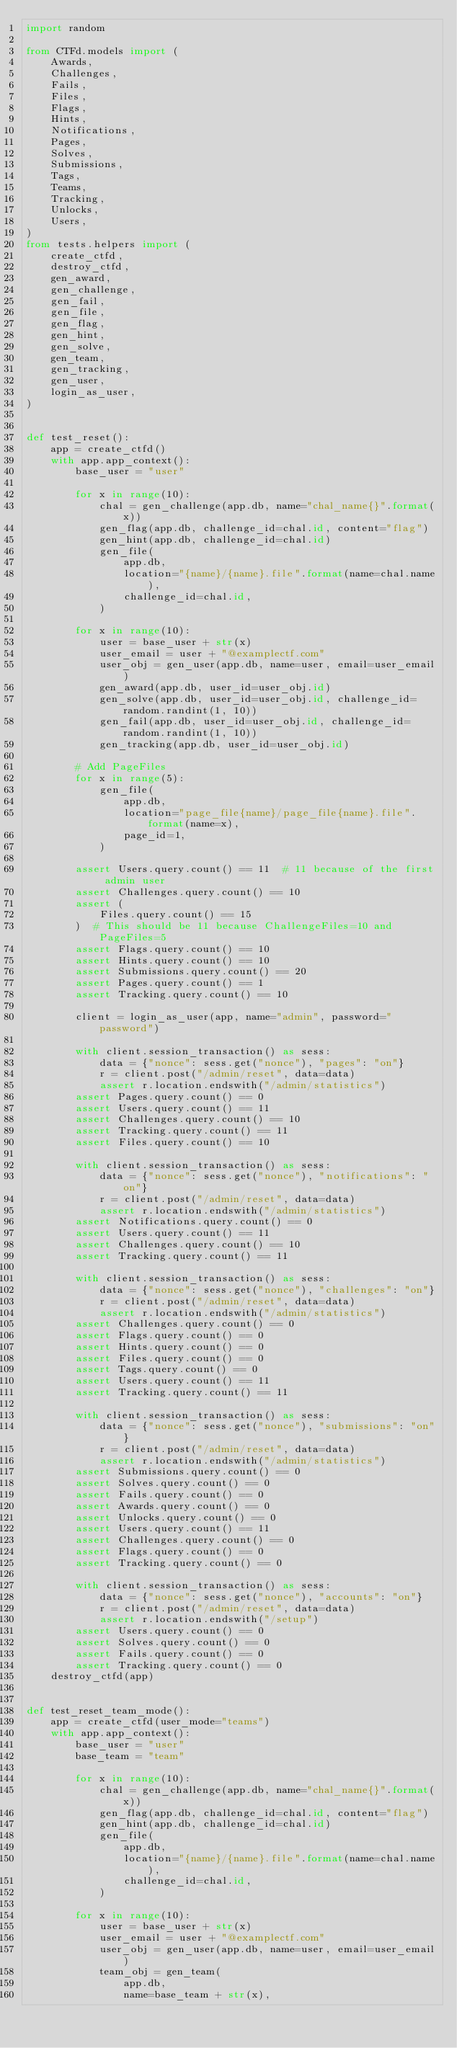<code> <loc_0><loc_0><loc_500><loc_500><_Python_>import random

from CTFd.models import (
    Awards,
    Challenges,
    Fails,
    Files,
    Flags,
    Hints,
    Notifications,
    Pages,
    Solves,
    Submissions,
    Tags,
    Teams,
    Tracking,
    Unlocks,
    Users,
)
from tests.helpers import (
    create_ctfd,
    destroy_ctfd,
    gen_award,
    gen_challenge,
    gen_fail,
    gen_file,
    gen_flag,
    gen_hint,
    gen_solve,
    gen_team,
    gen_tracking,
    gen_user,
    login_as_user,
)


def test_reset():
    app = create_ctfd()
    with app.app_context():
        base_user = "user"

        for x in range(10):
            chal = gen_challenge(app.db, name="chal_name{}".format(x))
            gen_flag(app.db, challenge_id=chal.id, content="flag")
            gen_hint(app.db, challenge_id=chal.id)
            gen_file(
                app.db,
                location="{name}/{name}.file".format(name=chal.name),
                challenge_id=chal.id,
            )

        for x in range(10):
            user = base_user + str(x)
            user_email = user + "@examplectf.com"
            user_obj = gen_user(app.db, name=user, email=user_email)
            gen_award(app.db, user_id=user_obj.id)
            gen_solve(app.db, user_id=user_obj.id, challenge_id=random.randint(1, 10))
            gen_fail(app.db, user_id=user_obj.id, challenge_id=random.randint(1, 10))
            gen_tracking(app.db, user_id=user_obj.id)

        # Add PageFiles
        for x in range(5):
            gen_file(
                app.db,
                location="page_file{name}/page_file{name}.file".format(name=x),
                page_id=1,
            )

        assert Users.query.count() == 11  # 11 because of the first admin user
        assert Challenges.query.count() == 10
        assert (
            Files.query.count() == 15
        )  # This should be 11 because ChallengeFiles=10 and PageFiles=5
        assert Flags.query.count() == 10
        assert Hints.query.count() == 10
        assert Submissions.query.count() == 20
        assert Pages.query.count() == 1
        assert Tracking.query.count() == 10

        client = login_as_user(app, name="admin", password="password")

        with client.session_transaction() as sess:
            data = {"nonce": sess.get("nonce"), "pages": "on"}
            r = client.post("/admin/reset", data=data)
            assert r.location.endswith("/admin/statistics")
        assert Pages.query.count() == 0
        assert Users.query.count() == 11
        assert Challenges.query.count() == 10
        assert Tracking.query.count() == 11
        assert Files.query.count() == 10

        with client.session_transaction() as sess:
            data = {"nonce": sess.get("nonce"), "notifications": "on"}
            r = client.post("/admin/reset", data=data)
            assert r.location.endswith("/admin/statistics")
        assert Notifications.query.count() == 0
        assert Users.query.count() == 11
        assert Challenges.query.count() == 10
        assert Tracking.query.count() == 11

        with client.session_transaction() as sess:
            data = {"nonce": sess.get("nonce"), "challenges": "on"}
            r = client.post("/admin/reset", data=data)
            assert r.location.endswith("/admin/statistics")
        assert Challenges.query.count() == 0
        assert Flags.query.count() == 0
        assert Hints.query.count() == 0
        assert Files.query.count() == 0
        assert Tags.query.count() == 0
        assert Users.query.count() == 11
        assert Tracking.query.count() == 11

        with client.session_transaction() as sess:
            data = {"nonce": sess.get("nonce"), "submissions": "on"}
            r = client.post("/admin/reset", data=data)
            assert r.location.endswith("/admin/statistics")
        assert Submissions.query.count() == 0
        assert Solves.query.count() == 0
        assert Fails.query.count() == 0
        assert Awards.query.count() == 0
        assert Unlocks.query.count() == 0
        assert Users.query.count() == 11
        assert Challenges.query.count() == 0
        assert Flags.query.count() == 0
        assert Tracking.query.count() == 0

        with client.session_transaction() as sess:
            data = {"nonce": sess.get("nonce"), "accounts": "on"}
            r = client.post("/admin/reset", data=data)
            assert r.location.endswith("/setup")
        assert Users.query.count() == 0
        assert Solves.query.count() == 0
        assert Fails.query.count() == 0
        assert Tracking.query.count() == 0
    destroy_ctfd(app)


def test_reset_team_mode():
    app = create_ctfd(user_mode="teams")
    with app.app_context():
        base_user = "user"
        base_team = "team"

        for x in range(10):
            chal = gen_challenge(app.db, name="chal_name{}".format(x))
            gen_flag(app.db, challenge_id=chal.id, content="flag")
            gen_hint(app.db, challenge_id=chal.id)
            gen_file(
                app.db,
                location="{name}/{name}.file".format(name=chal.name),
                challenge_id=chal.id,
            )

        for x in range(10):
            user = base_user + str(x)
            user_email = user + "@examplectf.com"
            user_obj = gen_user(app.db, name=user, email=user_email)
            team_obj = gen_team(
                app.db,
                name=base_team + str(x),</code> 